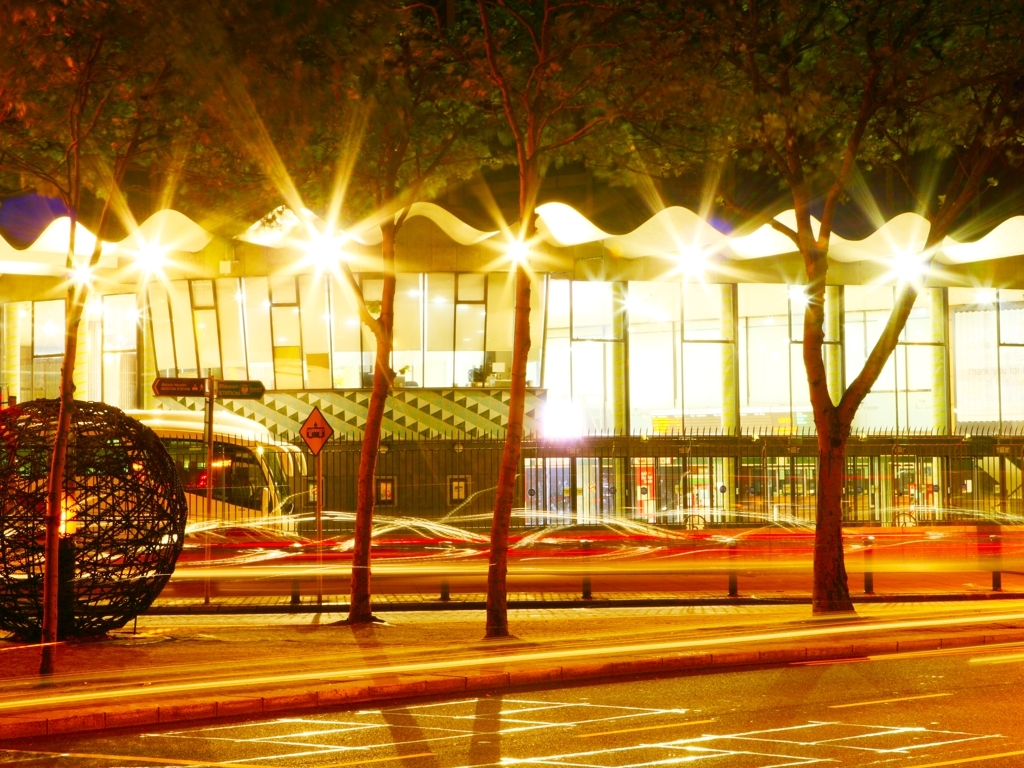What can you infer about the weather conditions when this photo was taken? The reflective quality of the road surface suggests that it might have recently rained, creating a wet surface that reflects the lights. The absence of people on the streets could also imply that the photo was taken shortly after a rain shower. Could this photograph's setting be indicative of any particular season? While it might be difficult to pinpoint the exact season without additional context, the presence of leaves on the trees suggests it is likely not winter. The overall ambience and the fact that leaves are visible suggest it could be during a warmer season, like spring or summer, or possibly early autumn before the leaves have fallen. 